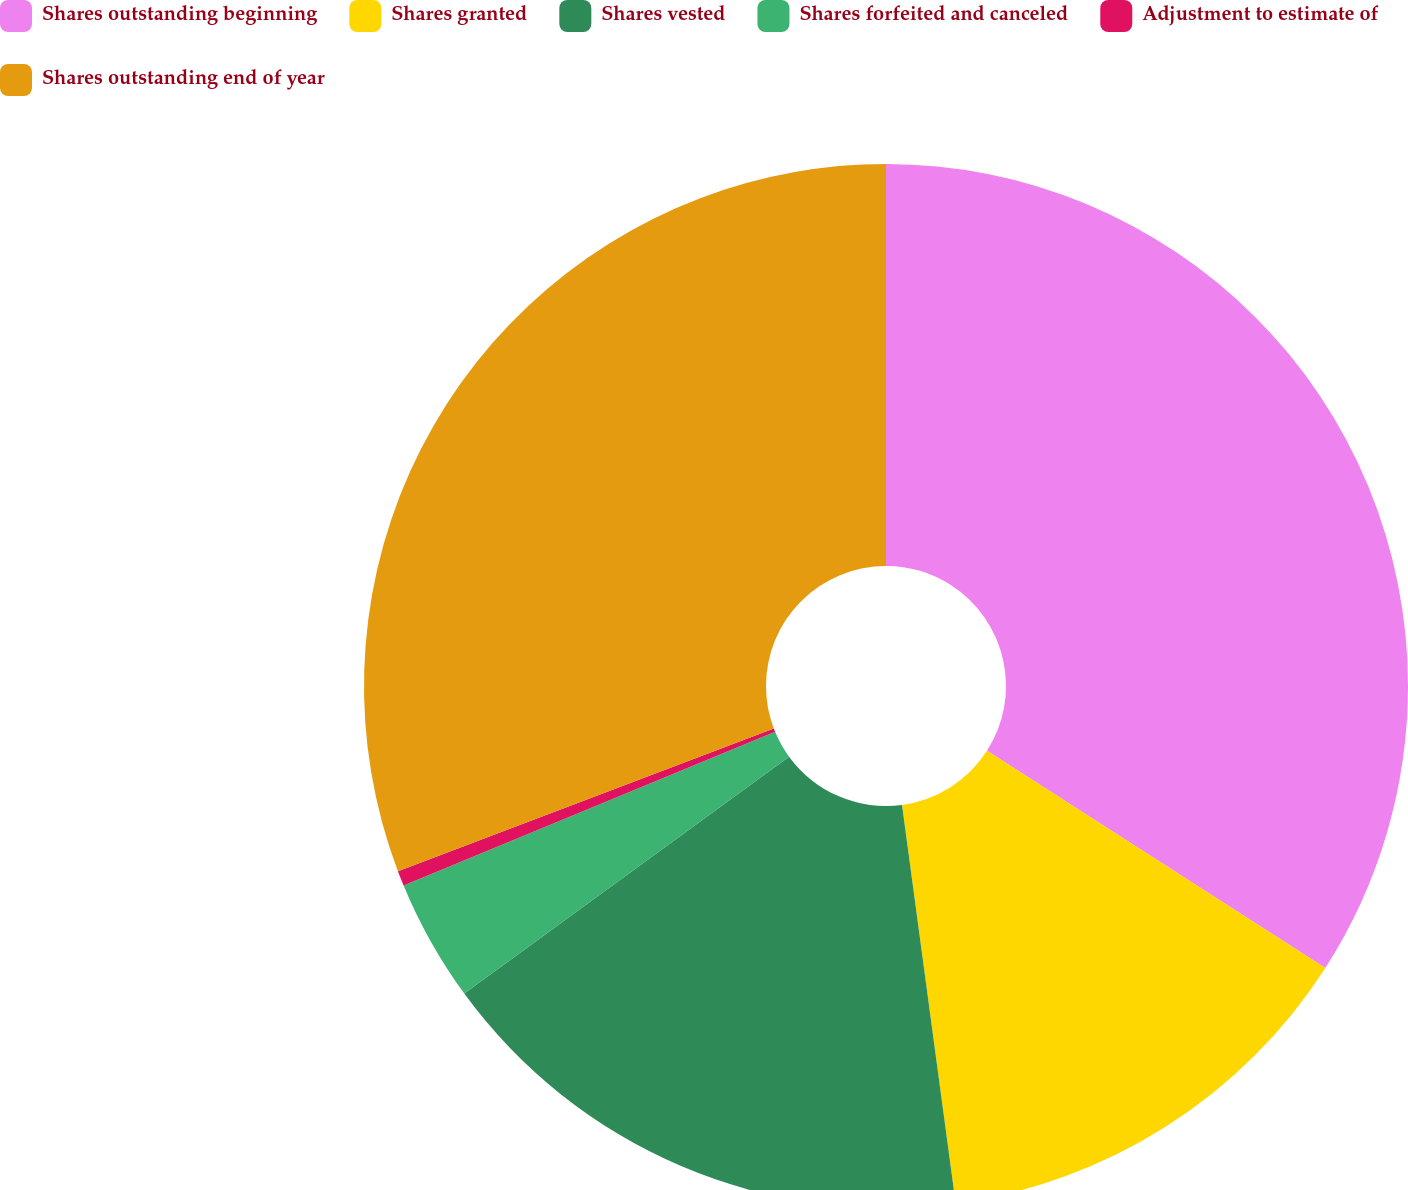Convert chart. <chart><loc_0><loc_0><loc_500><loc_500><pie_chart><fcel>Shares outstanding beginning<fcel>Shares granted<fcel>Shares vested<fcel>Shares forfeited and canceled<fcel>Adjustment to estimate of<fcel>Shares outstanding end of year<nl><fcel>34.08%<fcel>13.79%<fcel>17.1%<fcel>3.79%<fcel>0.47%<fcel>30.77%<nl></chart> 